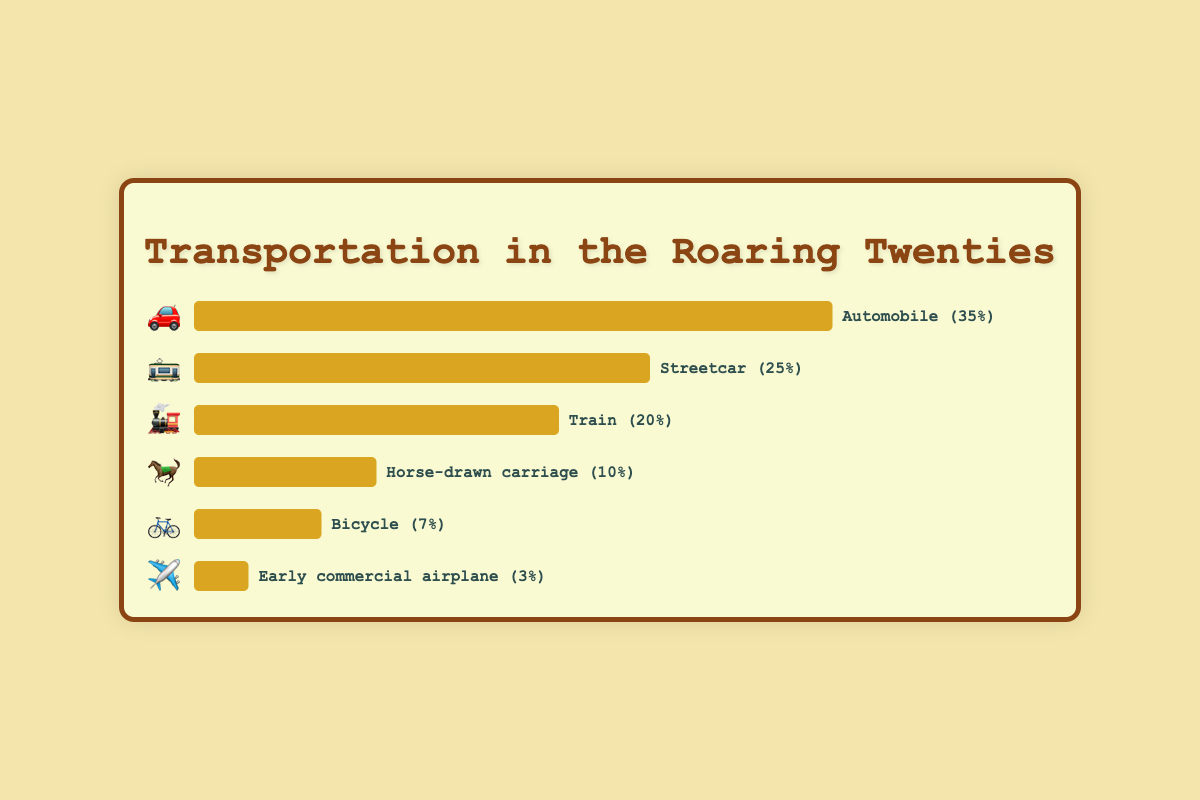What is the most popular transportation method? The chart shows that the bar representing automobiles is the longest, with a width representing 35%. Thus, automobiles are the most popular transportation method.
Answer: Automobiles Which transportation method is represented by the 🚋 emoji? The chart shows a list of transportation methods with corresponding emojis. The 🚋 emoji corresponds to the Streetcar.
Answer: Streetcar How much more popular is the automobile compared to the train? The popularity of the automobile is 35%, and the train is 20%. Subtracting these, 35% - 20% = 15%. Therefore, the automobile is 15% more popular than the train.
Answer: 15% Rank the transportation methods in descending order of popularity. By examining the lengths of the bars, the order from most to least popular is: Automobile (35%), Streetcar (25%), Train (20%), Horse-drawn carriage (10%), Bicycle (7%), Early commercial airplane (3%).
Answer: Automobile, Streetcar, Train, Horse-drawn carriage, Bicycle, Early commercial airplane What percentage of people used non-automobile methods of transportation? Adding the popularity of all transportation methods except the automobile: 25% (Streetcar) + 20% (Train) + 10% (Horse-drawn carriage) + 7% (Bicycle) + 3% (Early commercial airplane) = 65%.
Answer: 65% Which transportation method is represented by the 🐎 emoji, and what is its popularity? The chart shows that the 🐎 emoji corresponds to the Horse-drawn carriage, and its popularity is listed as 10%.
Answer: Horse-drawn carriage, 10% Which is more popular, bicycles or early commercial airplanes? By directly comparing the lengths of the bars, the bicycle has a popularity of 7%, while the early commercial airplane has 3%. Therefore, bicycles are more popular.
Answer: Bicycle How much less popular is the horse-drawn carriage compared to the streetcar? The streetcar has a popularity of 25%, and the horse-drawn carriage is 10%. Subtracting these, 25% - 10% = 15%. Therefore, the horse-drawn carriage is 15% less popular than the streetcar.
Answer: 15% What is the combined popularity of the Train and Bicycle methods? Adding the popularity percentages of Train and Bicycle gives: 20% (Train) + 7% (Bicycle) = 27%.
Answer: 27% What is the least popular transportation method and its emoji? The chart shows that the early commercial airplane has the smallest bar, representing 3% popularity. Its corresponding emoji is ✈️.
Answer: Early commercial airplane, ✈️ 